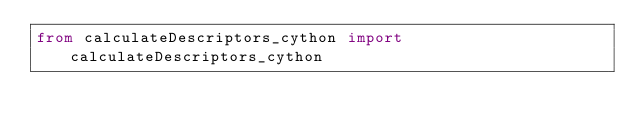<code> <loc_0><loc_0><loc_500><loc_500><_Python_>from calculateDescriptors_cython import calculateDescriptors_cython</code> 